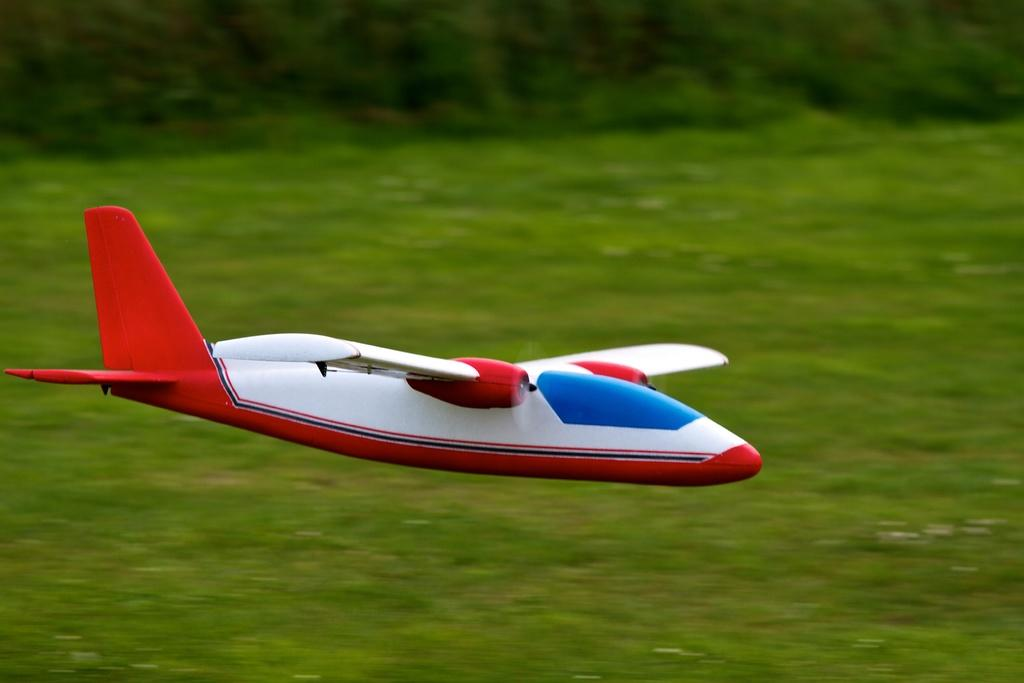What is the main subject of the image? The main subject of the image is a toy airplane. What is the toy airplane doing in the image? The toy airplane is flying in the air. What can be seen in the background of the image? There are trees visible in the background of the image. What type of insurance is required for the toy airplane in the image? There is no need for insurance for a toy airplane, as it is not a real aircraft. 